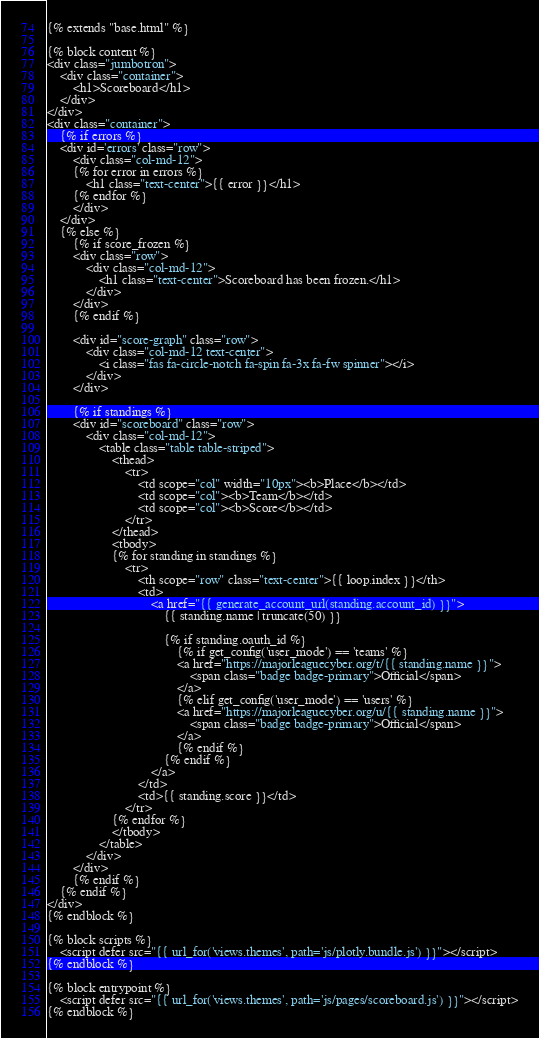<code> <loc_0><loc_0><loc_500><loc_500><_HTML_>{% extends "base.html" %}

{% block content %}
<div class="jumbotron">
	<div class="container">
		<h1>Scoreboard</h1>
	</div>
</div>
<div class="container">
	{% if errors %}
	<div id='errors' class="row">
		<div class="col-md-12">
		{% for error in errors %}
			<h1 class="text-center">{{ error }}</h1>
		{% endfor %}
		</div>
	</div>
	{% else %}
		{% if score_frozen %}
		<div class="row">
			<div class="col-md-12">
				<h1 class="text-center">Scoreboard has been frozen.</h1>
			</div>
		</div>
		{% endif %}

		<div id="score-graph" class="row">
			<div class="col-md-12 text-center">
				<i class="fas fa-circle-notch fa-spin fa-3x fa-fw spinner"></i>
			</div>
		</div>

		{% if standings %}
		<div id="scoreboard" class="row">
			<div class="col-md-12">
				<table class="table table-striped">
					<thead>
						<tr>
							<td scope="col" width="10px"><b>Place</b></td>
							<td scope="col"><b>Team</b></td>
							<td scope="col"><b>Score</b></td>
						</tr>
					</thead>
					<tbody>
					{% for standing in standings %}
						<tr>
							<th scope="row" class="text-center">{{ loop.index }}</th>
							<td>
								<a href="{{ generate_account_url(standing.account_id) }}">
									{{ standing.name | truncate(50) }}

									{% if standing.oauth_id %}
										{% if get_config('user_mode') == 'teams' %}
										<a href="https://majorleaguecyber.org/t/{{ standing.name }}">
											<span class="badge badge-primary">Official</span>
										</a>
										{% elif get_config('user_mode') == 'users' %}
										<a href="https://majorleaguecyber.org/u/{{ standing.name }}">
											<span class="badge badge-primary">Official</span>
										</a>
										{% endif %}
									{% endif %}
								</a>
							</td>
							<td>{{ standing.score }}</td>
						</tr>
					{% endfor %}
					</tbody>
				</table>
			</div>
		</div>
		{% endif %}
	{% endif %}
</div>
{% endblock %}

{% block scripts %}
	<script defer src="{{ url_for('views.themes', path='js/plotly.bundle.js') }}"></script>
{% endblock %}

{% block entrypoint %}
	<script defer src="{{ url_for('views.themes', path='js/pages/scoreboard.js') }}"></script>
{% endblock %}
</code> 